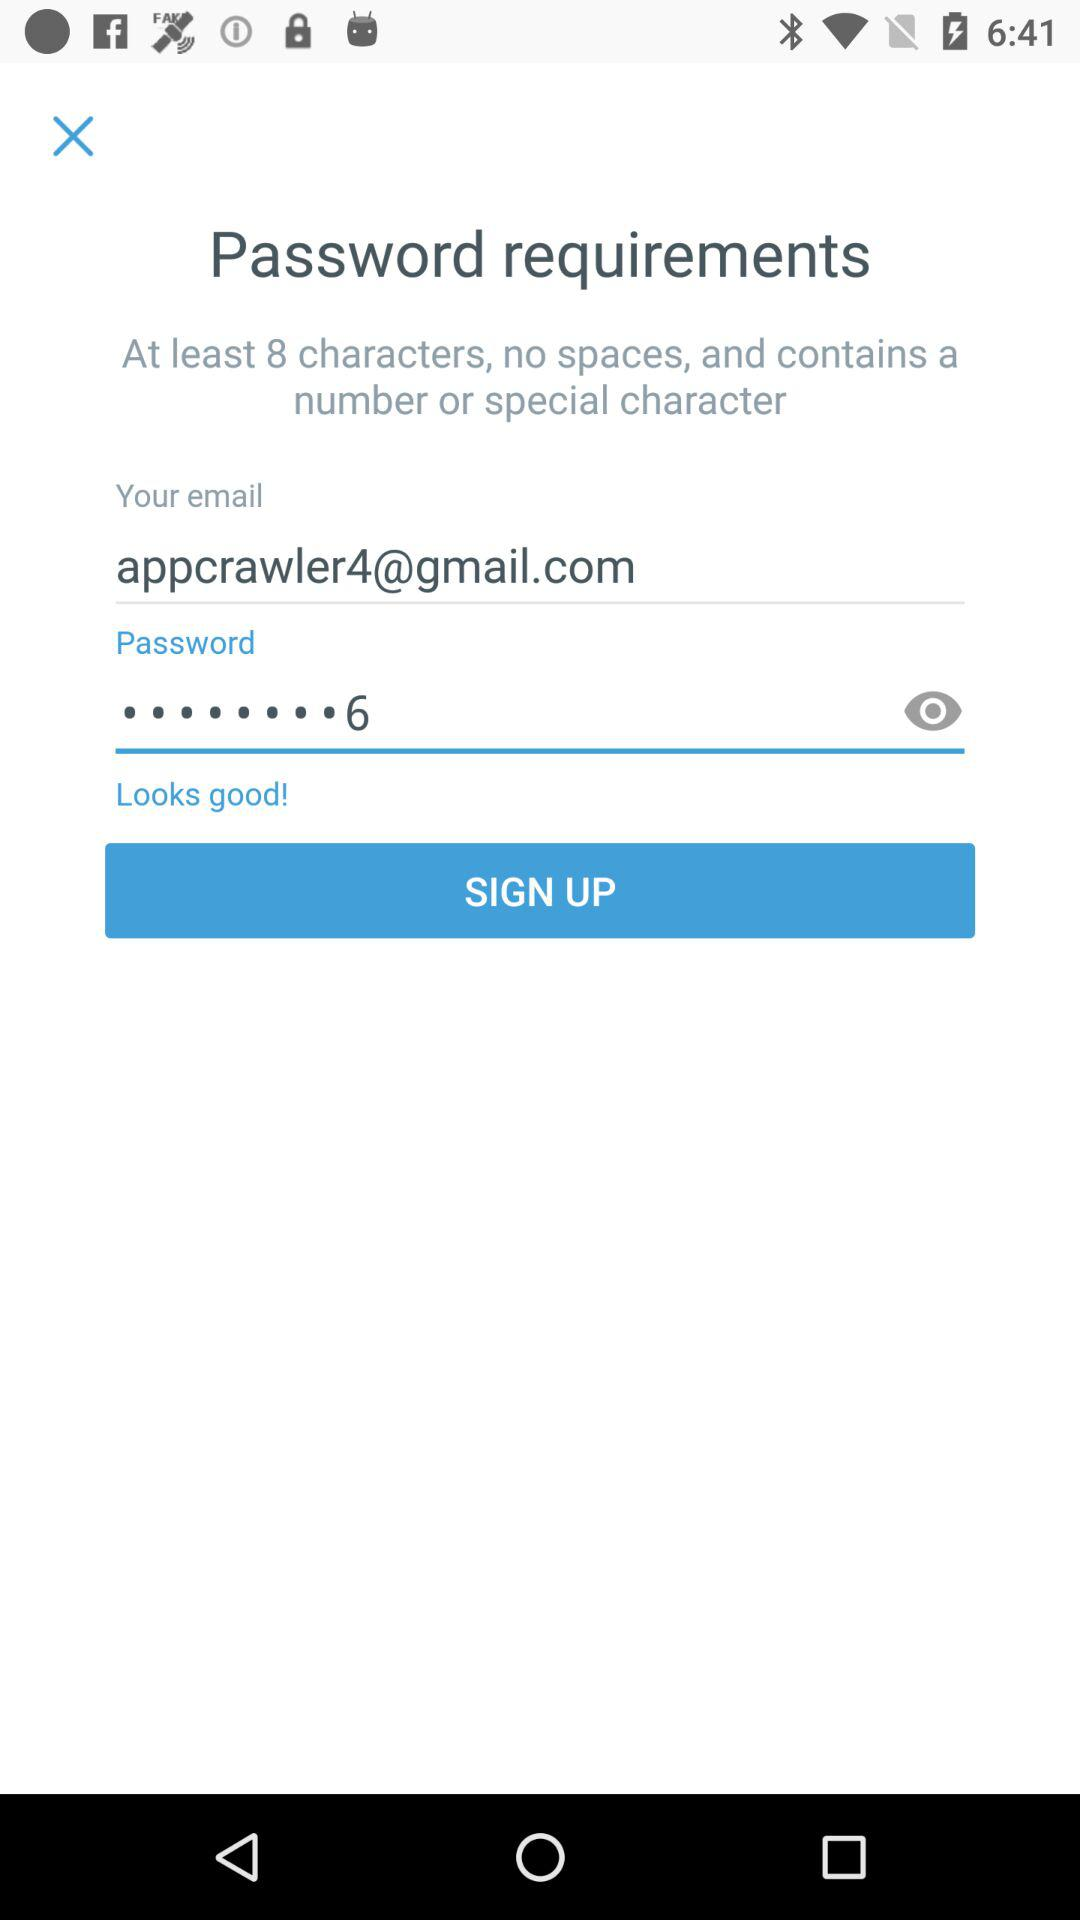How many characters are required to create the password? There are at least 8 characters required to create the password. 